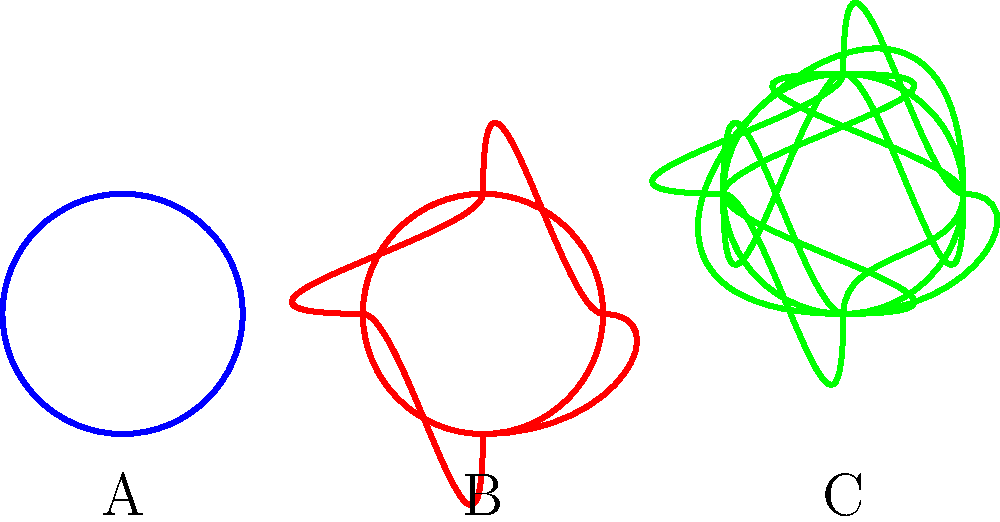As a competitive gamer, you're familiar with the concept of "knots" in complex strategy games. In knot theory, knots are classified based on their crossing diagrams. Consider the three knots shown above, labeled A, B, and C. Which of these knots has the highest crossing number, and what is that number? To solve this problem, we need to count the number of crossings in each knot diagram:

1. Knot A (Trefoil knot):
   - Count the number of times the line crosses over itself.
   - There are 3 crossings in this knot.

2. Knot B (Figure-eight knot):
   - Count the number of times the line crosses over itself.
   - There are 4 crossings in this knot.

3. Knot C (Cinquefoil knot):
   - Count the number of times the line crosses over itself.
   - There are 5 crossings in this knot.

The crossing number of a knot is the minimum number of crossings that occur in any diagram of the knot. In this case, these diagrams represent the minimal crossing numbers for each knot.

Comparing the crossing numbers:
A (Trefoil): 3
B (Figure-eight): 4
C (Cinquefoil): 5

Therefore, Knot C (Cinquefoil knot) has the highest crossing number, which is 5.
Answer: Knot C, 5 